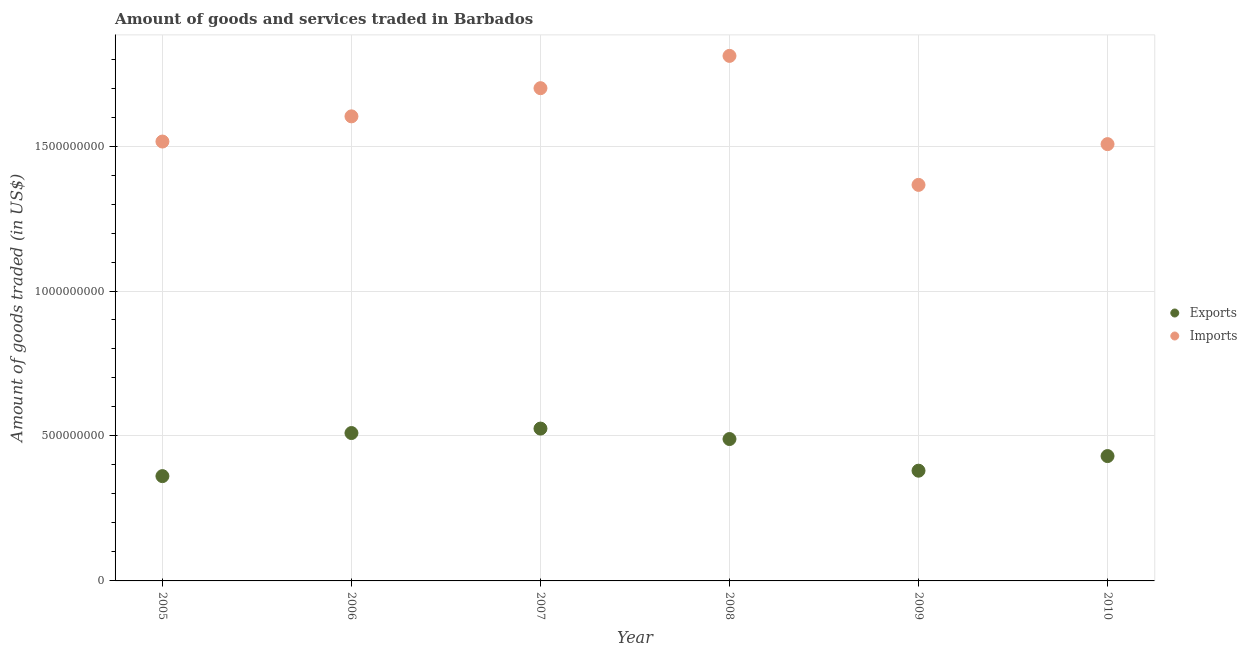How many different coloured dotlines are there?
Offer a terse response. 2. Is the number of dotlines equal to the number of legend labels?
Keep it short and to the point. Yes. What is the amount of goods imported in 2008?
Provide a succinct answer. 1.81e+09. Across all years, what is the maximum amount of goods exported?
Provide a short and direct response. 5.25e+08. Across all years, what is the minimum amount of goods imported?
Keep it short and to the point. 1.37e+09. What is the total amount of goods imported in the graph?
Keep it short and to the point. 9.50e+09. What is the difference between the amount of goods exported in 2005 and that in 2010?
Keep it short and to the point. -6.92e+07. What is the difference between the amount of goods imported in 2005 and the amount of goods exported in 2008?
Keep it short and to the point. 1.03e+09. What is the average amount of goods exported per year?
Ensure brevity in your answer.  4.50e+08. In the year 2009, what is the difference between the amount of goods exported and amount of goods imported?
Give a very brief answer. -9.86e+08. What is the ratio of the amount of goods imported in 2005 to that in 2010?
Ensure brevity in your answer.  1.01. Is the amount of goods imported in 2008 less than that in 2009?
Your response must be concise. No. What is the difference between the highest and the second highest amount of goods imported?
Give a very brief answer. 1.11e+08. What is the difference between the highest and the lowest amount of goods imported?
Provide a succinct answer. 4.45e+08. In how many years, is the amount of goods imported greater than the average amount of goods imported taken over all years?
Give a very brief answer. 3. Does the amount of goods imported monotonically increase over the years?
Your answer should be very brief. No. Is the amount of goods exported strictly greater than the amount of goods imported over the years?
Ensure brevity in your answer.  No. Is the amount of goods exported strictly less than the amount of goods imported over the years?
Provide a succinct answer. Yes. What is the difference between two consecutive major ticks on the Y-axis?
Give a very brief answer. 5.00e+08. Does the graph contain any zero values?
Your answer should be compact. No. Does the graph contain grids?
Give a very brief answer. Yes. Where does the legend appear in the graph?
Your answer should be very brief. Center right. How many legend labels are there?
Your answer should be very brief. 2. How are the legend labels stacked?
Offer a terse response. Vertical. What is the title of the graph?
Provide a succinct answer. Amount of goods and services traded in Barbados. What is the label or title of the Y-axis?
Keep it short and to the point. Amount of goods traded (in US$). What is the Amount of goods traded (in US$) in Exports in 2005?
Provide a succinct answer. 3.61e+08. What is the Amount of goods traded (in US$) in Imports in 2005?
Your answer should be compact. 1.52e+09. What is the Amount of goods traded (in US$) of Exports in 2006?
Provide a short and direct response. 5.10e+08. What is the Amount of goods traded (in US$) of Imports in 2006?
Your answer should be compact. 1.60e+09. What is the Amount of goods traded (in US$) in Exports in 2007?
Ensure brevity in your answer.  5.25e+08. What is the Amount of goods traded (in US$) of Imports in 2007?
Keep it short and to the point. 1.70e+09. What is the Amount of goods traded (in US$) of Exports in 2008?
Ensure brevity in your answer.  4.89e+08. What is the Amount of goods traded (in US$) in Imports in 2008?
Provide a succinct answer. 1.81e+09. What is the Amount of goods traded (in US$) in Exports in 2009?
Provide a succinct answer. 3.80e+08. What is the Amount of goods traded (in US$) of Imports in 2009?
Your response must be concise. 1.37e+09. What is the Amount of goods traded (in US$) in Exports in 2010?
Your answer should be compact. 4.31e+08. What is the Amount of goods traded (in US$) of Imports in 2010?
Offer a terse response. 1.51e+09. Across all years, what is the maximum Amount of goods traded (in US$) in Exports?
Your answer should be very brief. 5.25e+08. Across all years, what is the maximum Amount of goods traded (in US$) in Imports?
Give a very brief answer. 1.81e+09. Across all years, what is the minimum Amount of goods traded (in US$) of Exports?
Your response must be concise. 3.61e+08. Across all years, what is the minimum Amount of goods traded (in US$) of Imports?
Keep it short and to the point. 1.37e+09. What is the total Amount of goods traded (in US$) in Exports in the graph?
Your response must be concise. 2.70e+09. What is the total Amount of goods traded (in US$) of Imports in the graph?
Your answer should be compact. 9.50e+09. What is the difference between the Amount of goods traded (in US$) of Exports in 2005 and that in 2006?
Offer a very short reply. -1.49e+08. What is the difference between the Amount of goods traded (in US$) in Imports in 2005 and that in 2006?
Make the answer very short. -8.69e+07. What is the difference between the Amount of goods traded (in US$) in Exports in 2005 and that in 2007?
Provide a short and direct response. -1.64e+08. What is the difference between the Amount of goods traded (in US$) of Imports in 2005 and that in 2007?
Provide a succinct answer. -1.84e+08. What is the difference between the Amount of goods traded (in US$) in Exports in 2005 and that in 2008?
Give a very brief answer. -1.28e+08. What is the difference between the Amount of goods traded (in US$) in Imports in 2005 and that in 2008?
Offer a terse response. -2.95e+08. What is the difference between the Amount of goods traded (in US$) of Exports in 2005 and that in 2009?
Your answer should be compact. -1.87e+07. What is the difference between the Amount of goods traded (in US$) of Imports in 2005 and that in 2009?
Make the answer very short. 1.49e+08. What is the difference between the Amount of goods traded (in US$) in Exports in 2005 and that in 2010?
Your response must be concise. -6.92e+07. What is the difference between the Amount of goods traded (in US$) in Imports in 2005 and that in 2010?
Your response must be concise. 8.93e+06. What is the difference between the Amount of goods traded (in US$) in Exports in 2006 and that in 2007?
Give a very brief answer. -1.54e+07. What is the difference between the Amount of goods traded (in US$) of Imports in 2006 and that in 2007?
Your answer should be compact. -9.72e+07. What is the difference between the Amount of goods traded (in US$) in Exports in 2006 and that in 2008?
Give a very brief answer. 2.07e+07. What is the difference between the Amount of goods traded (in US$) in Imports in 2006 and that in 2008?
Ensure brevity in your answer.  -2.09e+08. What is the difference between the Amount of goods traded (in US$) in Exports in 2006 and that in 2009?
Your response must be concise. 1.30e+08. What is the difference between the Amount of goods traded (in US$) of Imports in 2006 and that in 2009?
Provide a succinct answer. 2.36e+08. What is the difference between the Amount of goods traded (in US$) in Exports in 2006 and that in 2010?
Give a very brief answer. 7.94e+07. What is the difference between the Amount of goods traded (in US$) in Imports in 2006 and that in 2010?
Offer a very short reply. 9.58e+07. What is the difference between the Amount of goods traded (in US$) in Exports in 2007 and that in 2008?
Offer a terse response. 3.60e+07. What is the difference between the Amount of goods traded (in US$) of Imports in 2007 and that in 2008?
Your answer should be very brief. -1.11e+08. What is the difference between the Amount of goods traded (in US$) of Exports in 2007 and that in 2009?
Your response must be concise. 1.45e+08. What is the difference between the Amount of goods traded (in US$) in Imports in 2007 and that in 2009?
Keep it short and to the point. 3.34e+08. What is the difference between the Amount of goods traded (in US$) of Exports in 2007 and that in 2010?
Your answer should be very brief. 9.48e+07. What is the difference between the Amount of goods traded (in US$) in Imports in 2007 and that in 2010?
Make the answer very short. 1.93e+08. What is the difference between the Amount of goods traded (in US$) in Exports in 2008 and that in 2009?
Provide a short and direct response. 1.09e+08. What is the difference between the Amount of goods traded (in US$) in Imports in 2008 and that in 2009?
Provide a succinct answer. 4.45e+08. What is the difference between the Amount of goods traded (in US$) of Exports in 2008 and that in 2010?
Offer a terse response. 5.88e+07. What is the difference between the Amount of goods traded (in US$) of Imports in 2008 and that in 2010?
Your answer should be very brief. 3.04e+08. What is the difference between the Amount of goods traded (in US$) of Exports in 2009 and that in 2010?
Your response must be concise. -5.04e+07. What is the difference between the Amount of goods traded (in US$) of Imports in 2009 and that in 2010?
Provide a short and direct response. -1.41e+08. What is the difference between the Amount of goods traded (in US$) in Exports in 2005 and the Amount of goods traded (in US$) in Imports in 2006?
Offer a terse response. -1.24e+09. What is the difference between the Amount of goods traded (in US$) of Exports in 2005 and the Amount of goods traded (in US$) of Imports in 2007?
Give a very brief answer. -1.34e+09. What is the difference between the Amount of goods traded (in US$) in Exports in 2005 and the Amount of goods traded (in US$) in Imports in 2008?
Ensure brevity in your answer.  -1.45e+09. What is the difference between the Amount of goods traded (in US$) of Exports in 2005 and the Amount of goods traded (in US$) of Imports in 2009?
Make the answer very short. -1.00e+09. What is the difference between the Amount of goods traded (in US$) of Exports in 2005 and the Amount of goods traded (in US$) of Imports in 2010?
Provide a short and direct response. -1.15e+09. What is the difference between the Amount of goods traded (in US$) in Exports in 2006 and the Amount of goods traded (in US$) in Imports in 2007?
Offer a terse response. -1.19e+09. What is the difference between the Amount of goods traded (in US$) in Exports in 2006 and the Amount of goods traded (in US$) in Imports in 2008?
Your answer should be compact. -1.30e+09. What is the difference between the Amount of goods traded (in US$) in Exports in 2006 and the Amount of goods traded (in US$) in Imports in 2009?
Offer a terse response. -8.56e+08. What is the difference between the Amount of goods traded (in US$) in Exports in 2006 and the Amount of goods traded (in US$) in Imports in 2010?
Your answer should be very brief. -9.97e+08. What is the difference between the Amount of goods traded (in US$) in Exports in 2007 and the Amount of goods traded (in US$) in Imports in 2008?
Offer a terse response. -1.29e+09. What is the difference between the Amount of goods traded (in US$) in Exports in 2007 and the Amount of goods traded (in US$) in Imports in 2009?
Your answer should be compact. -8.41e+08. What is the difference between the Amount of goods traded (in US$) in Exports in 2007 and the Amount of goods traded (in US$) in Imports in 2010?
Make the answer very short. -9.81e+08. What is the difference between the Amount of goods traded (in US$) in Exports in 2008 and the Amount of goods traded (in US$) in Imports in 2009?
Ensure brevity in your answer.  -8.77e+08. What is the difference between the Amount of goods traded (in US$) of Exports in 2008 and the Amount of goods traded (in US$) of Imports in 2010?
Provide a short and direct response. -1.02e+09. What is the difference between the Amount of goods traded (in US$) in Exports in 2009 and the Amount of goods traded (in US$) in Imports in 2010?
Provide a short and direct response. -1.13e+09. What is the average Amount of goods traded (in US$) of Exports per year?
Offer a very short reply. 4.50e+08. What is the average Amount of goods traded (in US$) of Imports per year?
Keep it short and to the point. 1.58e+09. In the year 2005, what is the difference between the Amount of goods traded (in US$) of Exports and Amount of goods traded (in US$) of Imports?
Make the answer very short. -1.15e+09. In the year 2006, what is the difference between the Amount of goods traded (in US$) in Exports and Amount of goods traded (in US$) in Imports?
Keep it short and to the point. -1.09e+09. In the year 2007, what is the difference between the Amount of goods traded (in US$) of Exports and Amount of goods traded (in US$) of Imports?
Ensure brevity in your answer.  -1.17e+09. In the year 2008, what is the difference between the Amount of goods traded (in US$) of Exports and Amount of goods traded (in US$) of Imports?
Ensure brevity in your answer.  -1.32e+09. In the year 2009, what is the difference between the Amount of goods traded (in US$) in Exports and Amount of goods traded (in US$) in Imports?
Give a very brief answer. -9.86e+08. In the year 2010, what is the difference between the Amount of goods traded (in US$) of Exports and Amount of goods traded (in US$) of Imports?
Give a very brief answer. -1.08e+09. What is the ratio of the Amount of goods traded (in US$) of Exports in 2005 to that in 2006?
Make the answer very short. 0.71. What is the ratio of the Amount of goods traded (in US$) of Imports in 2005 to that in 2006?
Ensure brevity in your answer.  0.95. What is the ratio of the Amount of goods traded (in US$) of Exports in 2005 to that in 2007?
Offer a very short reply. 0.69. What is the ratio of the Amount of goods traded (in US$) in Imports in 2005 to that in 2007?
Your response must be concise. 0.89. What is the ratio of the Amount of goods traded (in US$) of Exports in 2005 to that in 2008?
Offer a terse response. 0.74. What is the ratio of the Amount of goods traded (in US$) in Imports in 2005 to that in 2008?
Your response must be concise. 0.84. What is the ratio of the Amount of goods traded (in US$) in Exports in 2005 to that in 2009?
Keep it short and to the point. 0.95. What is the ratio of the Amount of goods traded (in US$) in Imports in 2005 to that in 2009?
Ensure brevity in your answer.  1.11. What is the ratio of the Amount of goods traded (in US$) in Exports in 2005 to that in 2010?
Offer a very short reply. 0.84. What is the ratio of the Amount of goods traded (in US$) of Imports in 2005 to that in 2010?
Give a very brief answer. 1.01. What is the ratio of the Amount of goods traded (in US$) in Exports in 2006 to that in 2007?
Your answer should be very brief. 0.97. What is the ratio of the Amount of goods traded (in US$) in Imports in 2006 to that in 2007?
Provide a succinct answer. 0.94. What is the ratio of the Amount of goods traded (in US$) of Exports in 2006 to that in 2008?
Give a very brief answer. 1.04. What is the ratio of the Amount of goods traded (in US$) in Imports in 2006 to that in 2008?
Make the answer very short. 0.88. What is the ratio of the Amount of goods traded (in US$) of Exports in 2006 to that in 2009?
Provide a short and direct response. 1.34. What is the ratio of the Amount of goods traded (in US$) in Imports in 2006 to that in 2009?
Keep it short and to the point. 1.17. What is the ratio of the Amount of goods traded (in US$) in Exports in 2006 to that in 2010?
Your response must be concise. 1.18. What is the ratio of the Amount of goods traded (in US$) in Imports in 2006 to that in 2010?
Make the answer very short. 1.06. What is the ratio of the Amount of goods traded (in US$) of Exports in 2007 to that in 2008?
Your answer should be compact. 1.07. What is the ratio of the Amount of goods traded (in US$) in Imports in 2007 to that in 2008?
Make the answer very short. 0.94. What is the ratio of the Amount of goods traded (in US$) in Exports in 2007 to that in 2009?
Offer a terse response. 1.38. What is the ratio of the Amount of goods traded (in US$) in Imports in 2007 to that in 2009?
Provide a short and direct response. 1.24. What is the ratio of the Amount of goods traded (in US$) of Exports in 2007 to that in 2010?
Keep it short and to the point. 1.22. What is the ratio of the Amount of goods traded (in US$) of Imports in 2007 to that in 2010?
Keep it short and to the point. 1.13. What is the ratio of the Amount of goods traded (in US$) of Exports in 2008 to that in 2009?
Provide a short and direct response. 1.29. What is the ratio of the Amount of goods traded (in US$) in Imports in 2008 to that in 2009?
Give a very brief answer. 1.33. What is the ratio of the Amount of goods traded (in US$) in Exports in 2008 to that in 2010?
Make the answer very short. 1.14. What is the ratio of the Amount of goods traded (in US$) of Imports in 2008 to that in 2010?
Offer a very short reply. 1.2. What is the ratio of the Amount of goods traded (in US$) of Exports in 2009 to that in 2010?
Give a very brief answer. 0.88. What is the ratio of the Amount of goods traded (in US$) of Imports in 2009 to that in 2010?
Give a very brief answer. 0.91. What is the difference between the highest and the second highest Amount of goods traded (in US$) of Exports?
Ensure brevity in your answer.  1.54e+07. What is the difference between the highest and the second highest Amount of goods traded (in US$) of Imports?
Your answer should be very brief. 1.11e+08. What is the difference between the highest and the lowest Amount of goods traded (in US$) of Exports?
Provide a short and direct response. 1.64e+08. What is the difference between the highest and the lowest Amount of goods traded (in US$) of Imports?
Offer a terse response. 4.45e+08. 